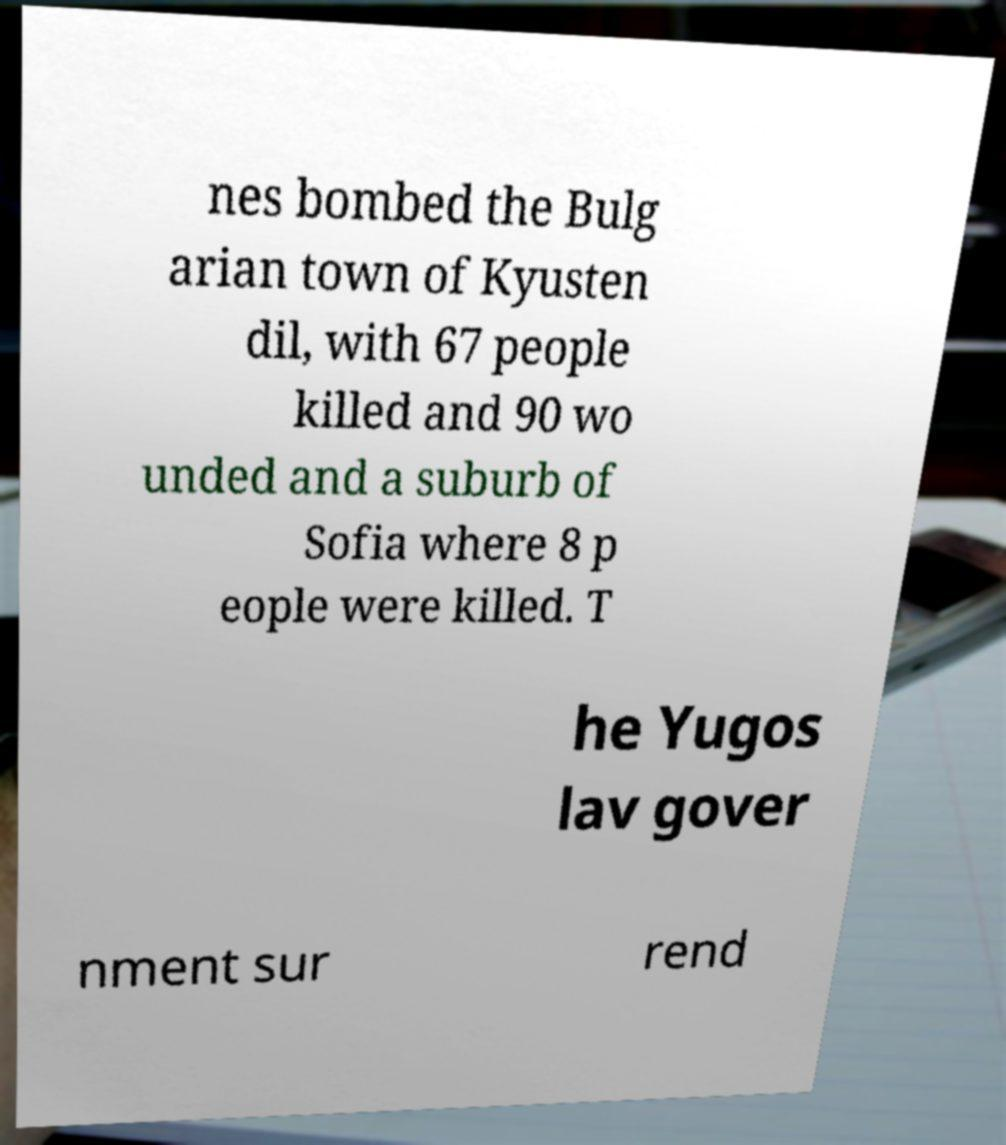For documentation purposes, I need the text within this image transcribed. Could you provide that? nes bombed the Bulg arian town of Kyusten dil, with 67 people killed and 90 wo unded and a suburb of Sofia where 8 p eople were killed. T he Yugos lav gover nment sur rend 